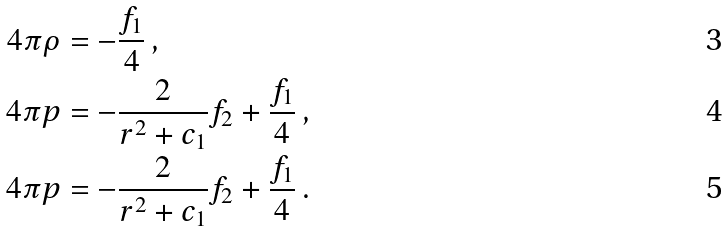Convert formula to latex. <formula><loc_0><loc_0><loc_500><loc_500>4 \pi \rho & = - \frac { f _ { 1 } } { 4 } \, , \\ 4 \pi p & = - \frac { 2 } { r ^ { 2 } + c _ { 1 } } f _ { 2 } + \frac { f _ { 1 } } { 4 } \, , \\ 4 \pi p & = - \frac { 2 } { r ^ { 2 } + c _ { 1 } } f _ { 2 } + \frac { f _ { 1 } } { 4 } \, .</formula> 